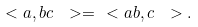Convert formula to latex. <formula><loc_0><loc_0><loc_500><loc_500>\ < a , b c \ > = \ < a b , c \ > .</formula> 